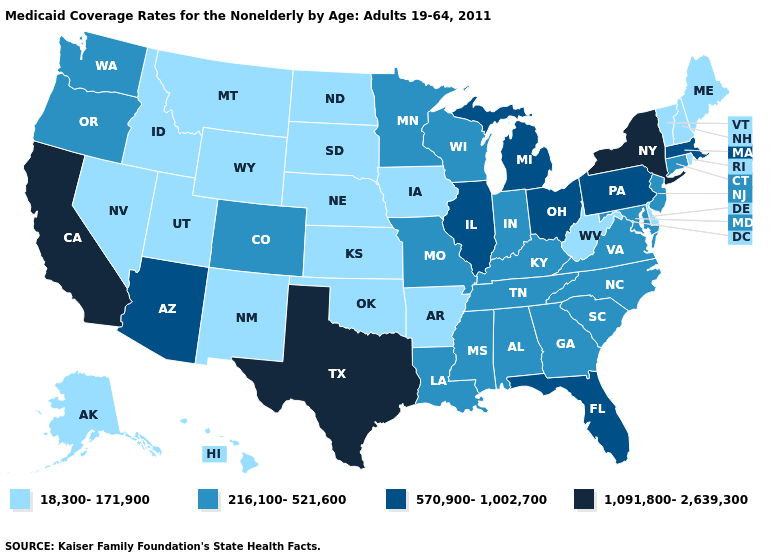Name the states that have a value in the range 570,900-1,002,700?
Keep it brief. Arizona, Florida, Illinois, Massachusetts, Michigan, Ohio, Pennsylvania. Among the states that border Utah , does Wyoming have the highest value?
Give a very brief answer. No. Among the states that border Arizona , which have the highest value?
Keep it brief. California. What is the lowest value in the South?
Be succinct. 18,300-171,900. What is the value of Iowa?
Give a very brief answer. 18,300-171,900. What is the value of Idaho?
Keep it brief. 18,300-171,900. How many symbols are there in the legend?
Concise answer only. 4. Name the states that have a value in the range 570,900-1,002,700?
Short answer required. Arizona, Florida, Illinois, Massachusetts, Michigan, Ohio, Pennsylvania. Name the states that have a value in the range 570,900-1,002,700?
Give a very brief answer. Arizona, Florida, Illinois, Massachusetts, Michigan, Ohio, Pennsylvania. Name the states that have a value in the range 1,091,800-2,639,300?
Short answer required. California, New York, Texas. Among the states that border Vermont , which have the highest value?
Be succinct. New York. How many symbols are there in the legend?
Quick response, please. 4. Among the states that border Wisconsin , does Illinois have the lowest value?
Be succinct. No. Does Ohio have the highest value in the MidWest?
Be succinct. Yes. 